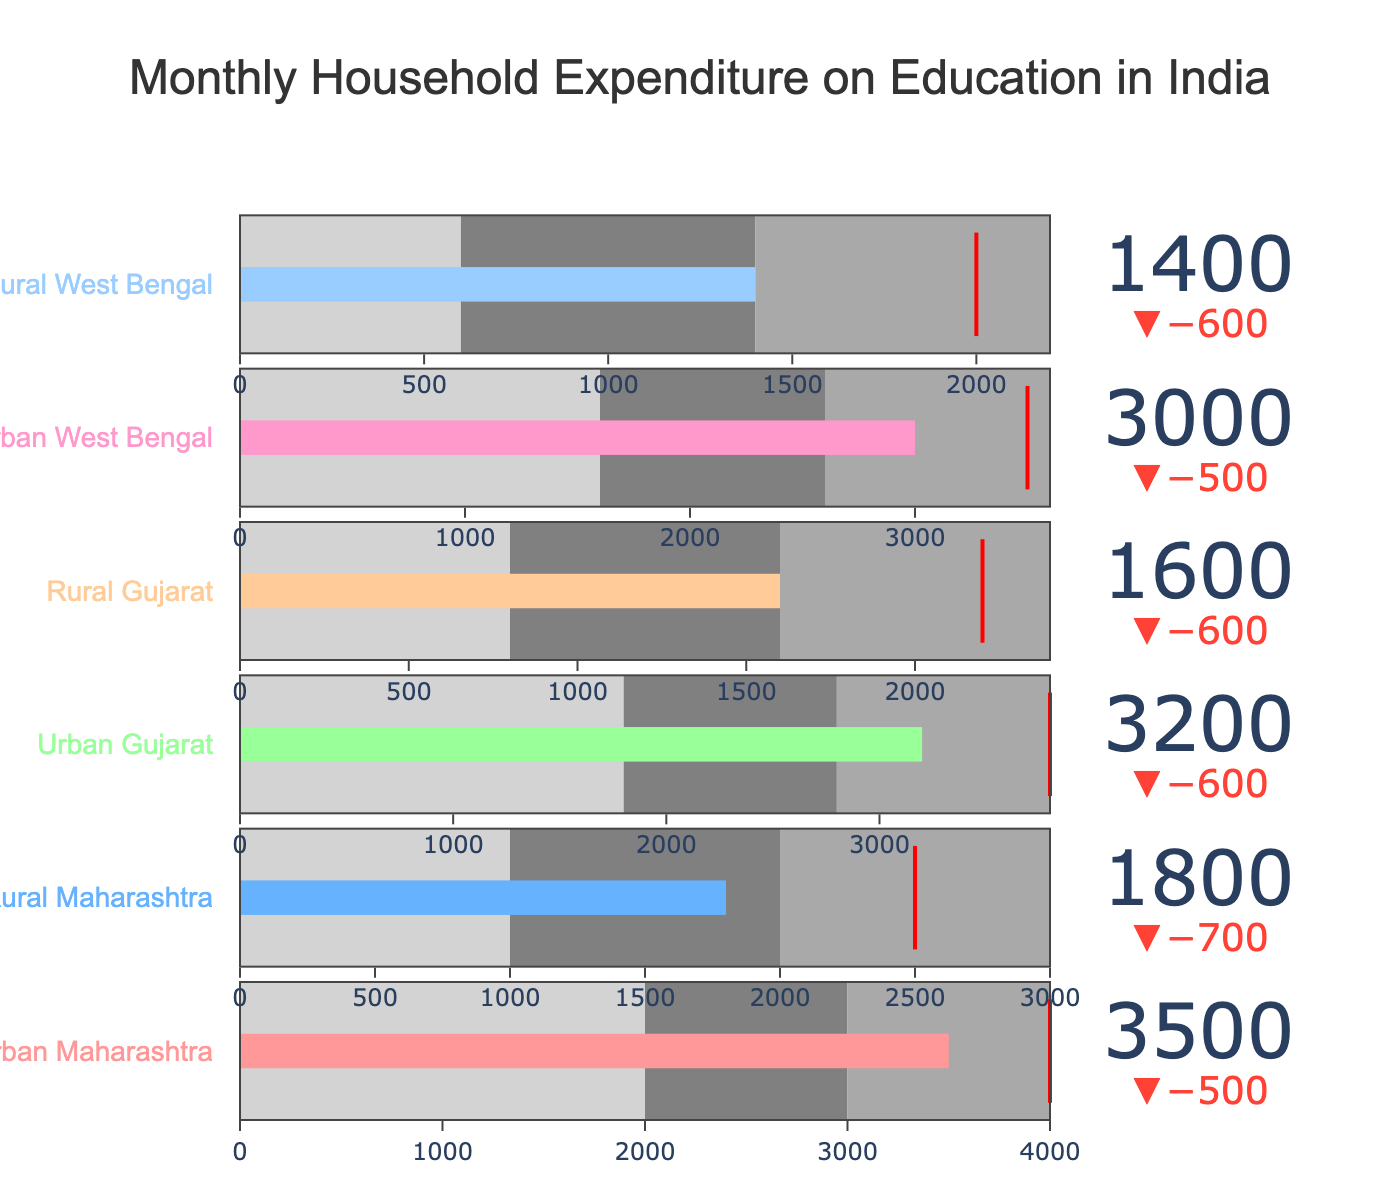What is the title of the figure? The title of the figure is displayed centrally at the top. It states "Monthly Household Expenditure on Education in India".
Answer: Monthly Household Expenditure on Education in India How much is the actual expenditure for Urban West Bengal? The actual expenditure is the value indicated by the gauge bar for Urban West Bengal. It is 3000.
Answer: 3000 What is the target expenditure for Rural Maharashtra? The target expenditure is indicated by the red threshold line on the gauge for Rural Maharashtra. It is 2500.
Answer: 2500 Compare the actual expenditure between Urban Maharashtra and Rural Maharashtra. The actual expenditure for Urban Maharashtra is 3500 and for Rural Maharashtra is 1800. By comparing these values, we see that Urban Maharashtra’s expenditure is higher.
Answer: Urban Maharashtra Is the actual expenditure for Rural West Bengal above or below the target? The actual expenditure for Rural West Bengal is 1400, and the target is 2000. Since 1400 is less than 2000, the expenditure is below the target.
Answer: Below What's the difference between the target and actual expenditure for Urban Gujarat? The target expenditure for Urban Gujarat is 3800, and the actual expenditure is 3200. The difference is calculated as 3800 - 3200 = 600.
Answer: 600 Which area has the smallest actual expenditure? By looking at all the actual expenditure values, Rural West Bengal has the smallest value, which is 1400.
Answer: Rural West Bengal How many different expenditure categories are represented in the chart? Each category title indicates a different expenditure group, and there are six of them listed.
Answer: 6 For which area is the actual expenditure closest to its target? Comparing the actual to target differences: Urban Maharashtra (500), Rural Maharashtra (700), Urban Gujarat (600), Rural Gujarat (600), Urban West Bengal (500), and Rural West Bengal (600). Urban Maharashtra and Urban West Bengal are the closest.
Answer: Urban Maharashtra and Urban West Bengal Which areas have an actual expenditure that lies in the second range category? The second range category is indicated by the middle color band. Rural Maharashtra (actual 1800, second range up to 2000) and Urban West Bengal (actual 3000, second range up to 2600) both have their expenditures within these ranges.
Answer: Rural Maharashtra and Urban West Bengal 